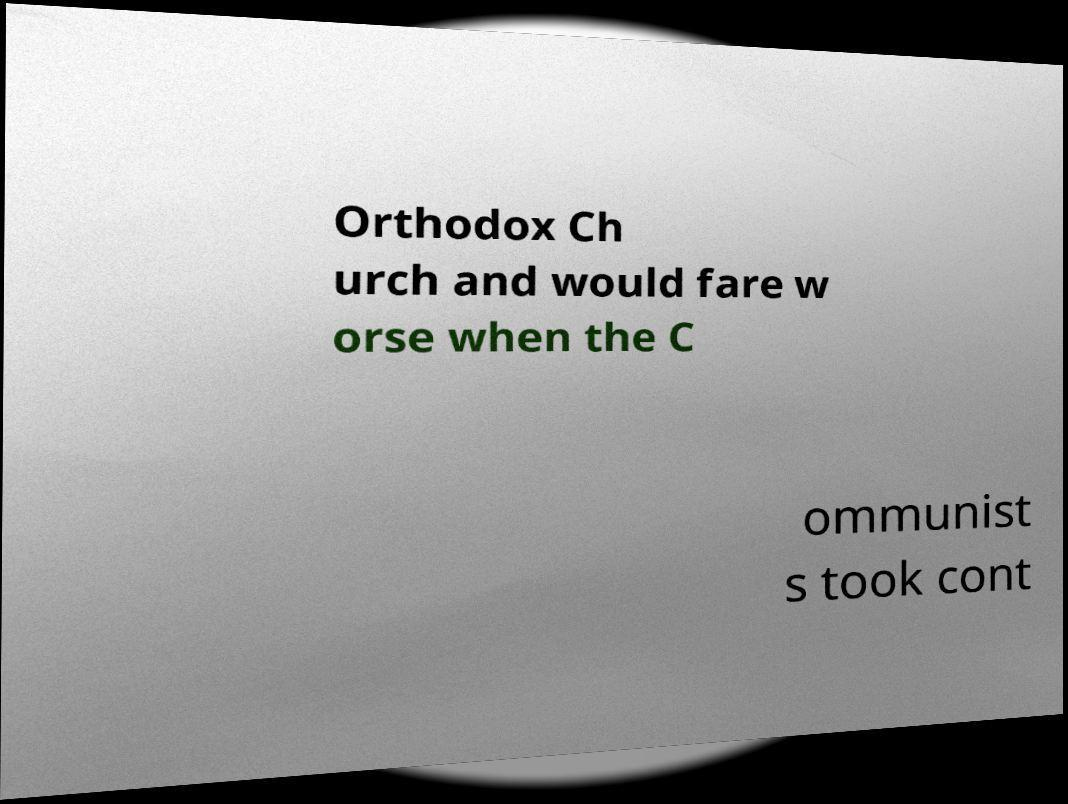Could you assist in decoding the text presented in this image and type it out clearly? Orthodox Ch urch and would fare w orse when the C ommunist s took cont 